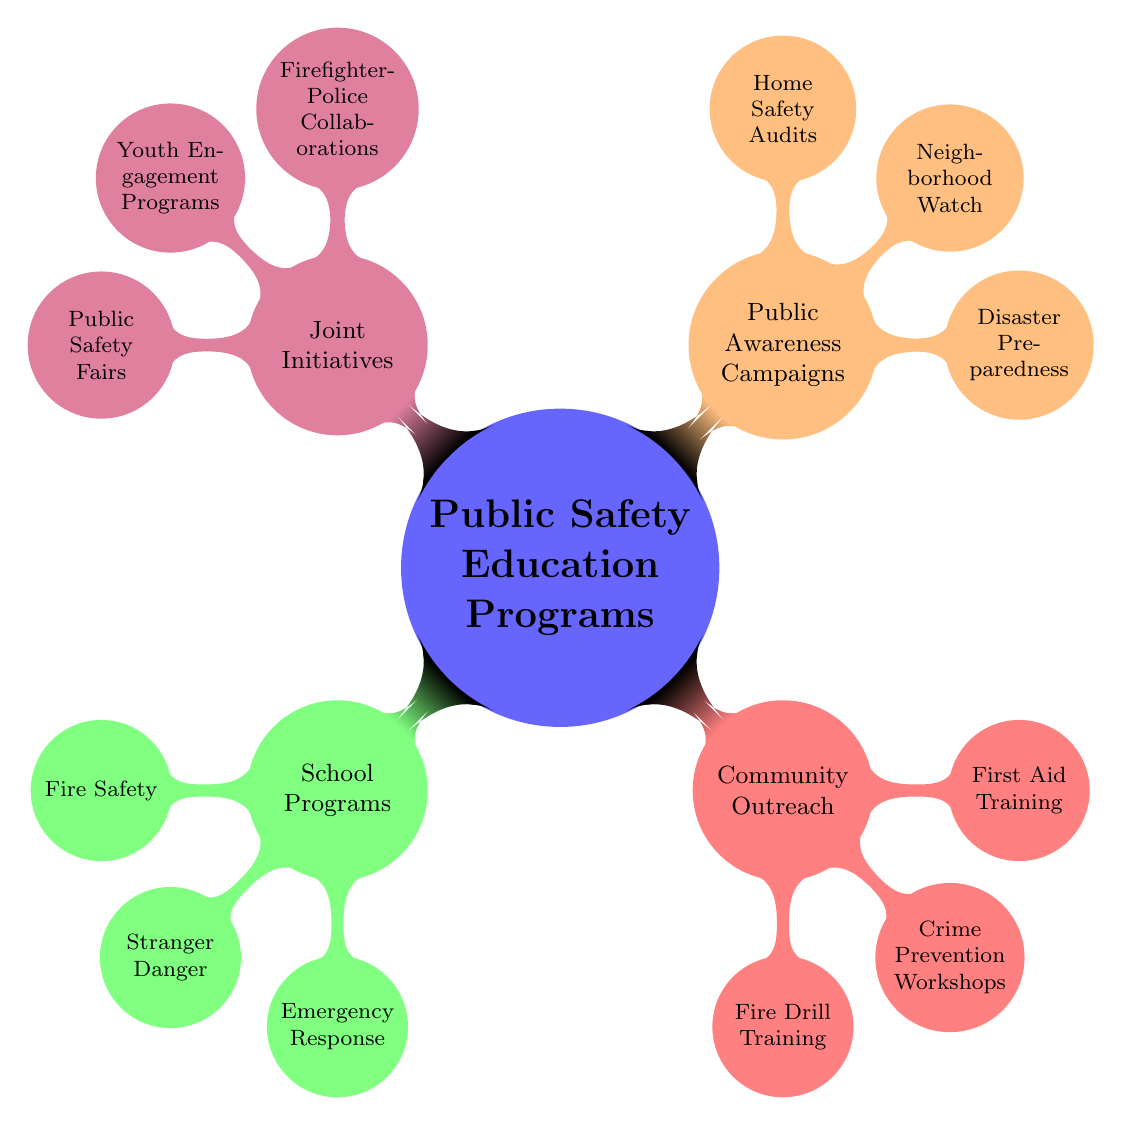What is the main topic of the mind map? The central node of the mind map indicates the main topic, which is "Public Safety Education Programs."
Answer: Public Safety Education Programs How many categories are there under "Public Safety Education Programs"? The mind map branches into four categories: School Programs, Community Outreach, Public Awareness Campaigns, and Joint Initiatives. Counting these branches gives a total of four categories.
Answer: 4 Which category contains "Emergency Response"? The node labeled "Emergency Response" is under the "School Programs" category.
Answer: School Programs What collaboration is mentioned in the "Joint Initiatives" category? The "Joint Initiatives" category includes a collaboration between firefighters and police as represented by the node "Firefighter-Police Collaborations."
Answer: Firefighter-Police Collaborations Which program involves the Red Cross? The "First Aid Training" node mentions collaboration with the Red Cross as part of the "Community Outreach" category.
Answer: First Aid Training What training occurs at community centers? The diagram specifies that "Fire Drill Training" takes place at community centers, which is part of the "Community Outreach" category.
Answer: Fire Drill Training Which public safety program focuses on neighborhood safety? The node "Neighborhood Watch" found in the "Public Awareness Campaigns" category addresses neighborhood safety.
Answer: Neighborhood Watch What type of events does the diagram include for community engagement? "Public Safety Fairs" are highlighted as a form of engagement within the "Joint Initiatives" category.
Answer: Public Safety Fairs How does the "Emergency Response" program help the community? The "Emergency Response" program involves "911 Simulation Drills," which provide practice on how to respond in emergencies.
Answer: 911 Simulation Drills 